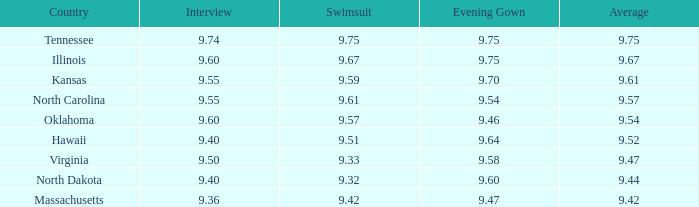What was the evening dress score when the bathing suit was 9.54. 